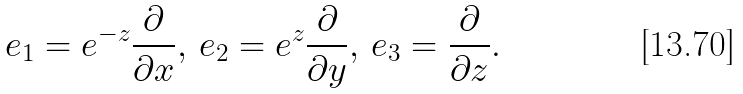Convert formula to latex. <formula><loc_0><loc_0><loc_500><loc_500>e _ { 1 } = e ^ { - z } \frac { \partial } { \partial x } , \, e _ { 2 } = e ^ { z } \frac { \partial } { \partial y } , \, e _ { 3 } = \frac { \partial } { \partial z } .</formula> 